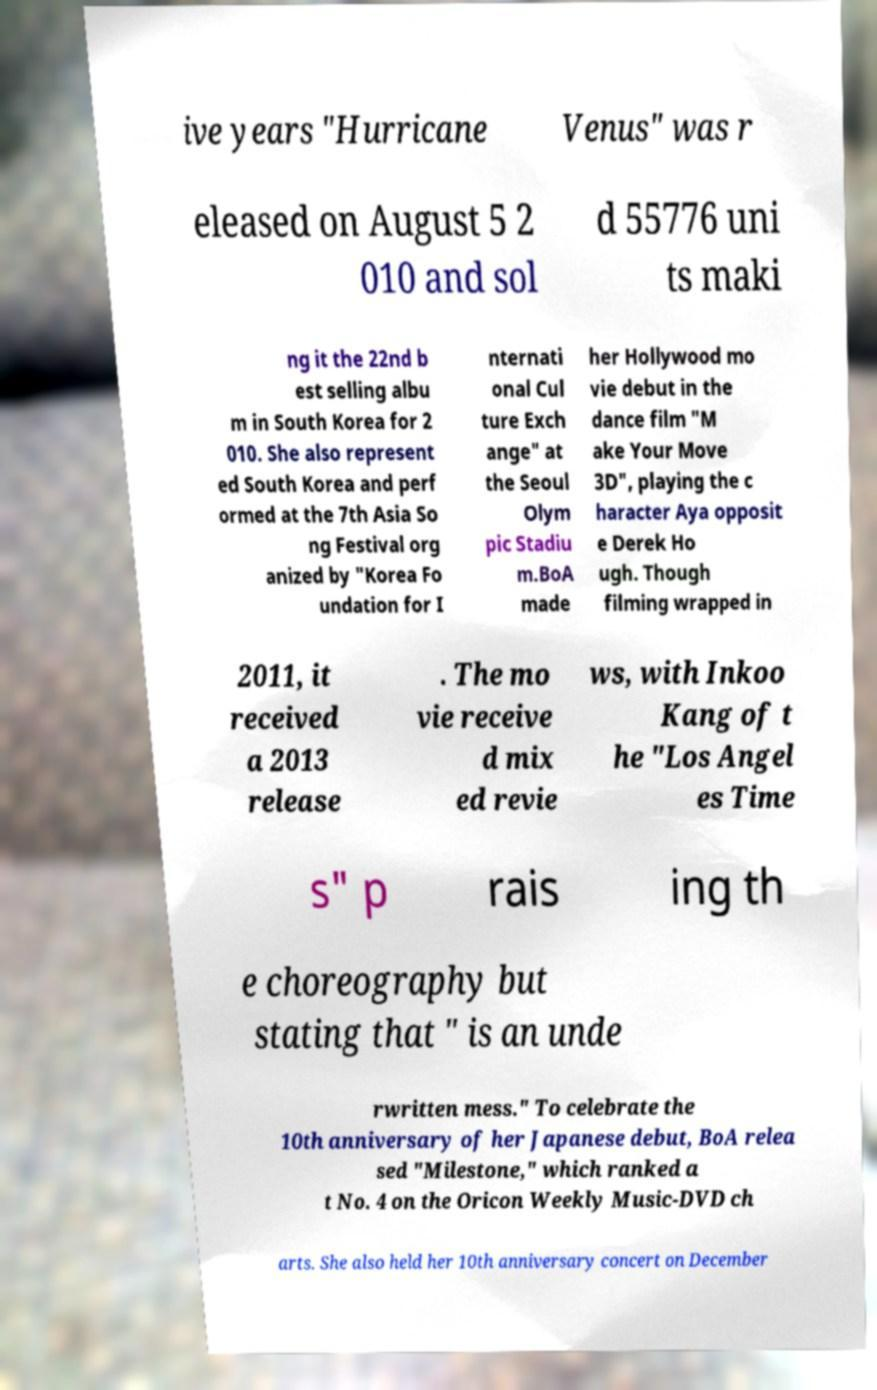Please read and relay the text visible in this image. What does it say? ive years "Hurricane Venus" was r eleased on August 5 2 010 and sol d 55776 uni ts maki ng it the 22nd b est selling albu m in South Korea for 2 010. She also represent ed South Korea and perf ormed at the 7th Asia So ng Festival org anized by "Korea Fo undation for I nternati onal Cul ture Exch ange" at the Seoul Olym pic Stadiu m.BoA made her Hollywood mo vie debut in the dance film "M ake Your Move 3D", playing the c haracter Aya opposit e Derek Ho ugh. Though filming wrapped in 2011, it received a 2013 release . The mo vie receive d mix ed revie ws, with Inkoo Kang of t he "Los Angel es Time s" p rais ing th e choreography but stating that " is an unde rwritten mess." To celebrate the 10th anniversary of her Japanese debut, BoA relea sed "Milestone," which ranked a t No. 4 on the Oricon Weekly Music-DVD ch arts. She also held her 10th anniversary concert on December 